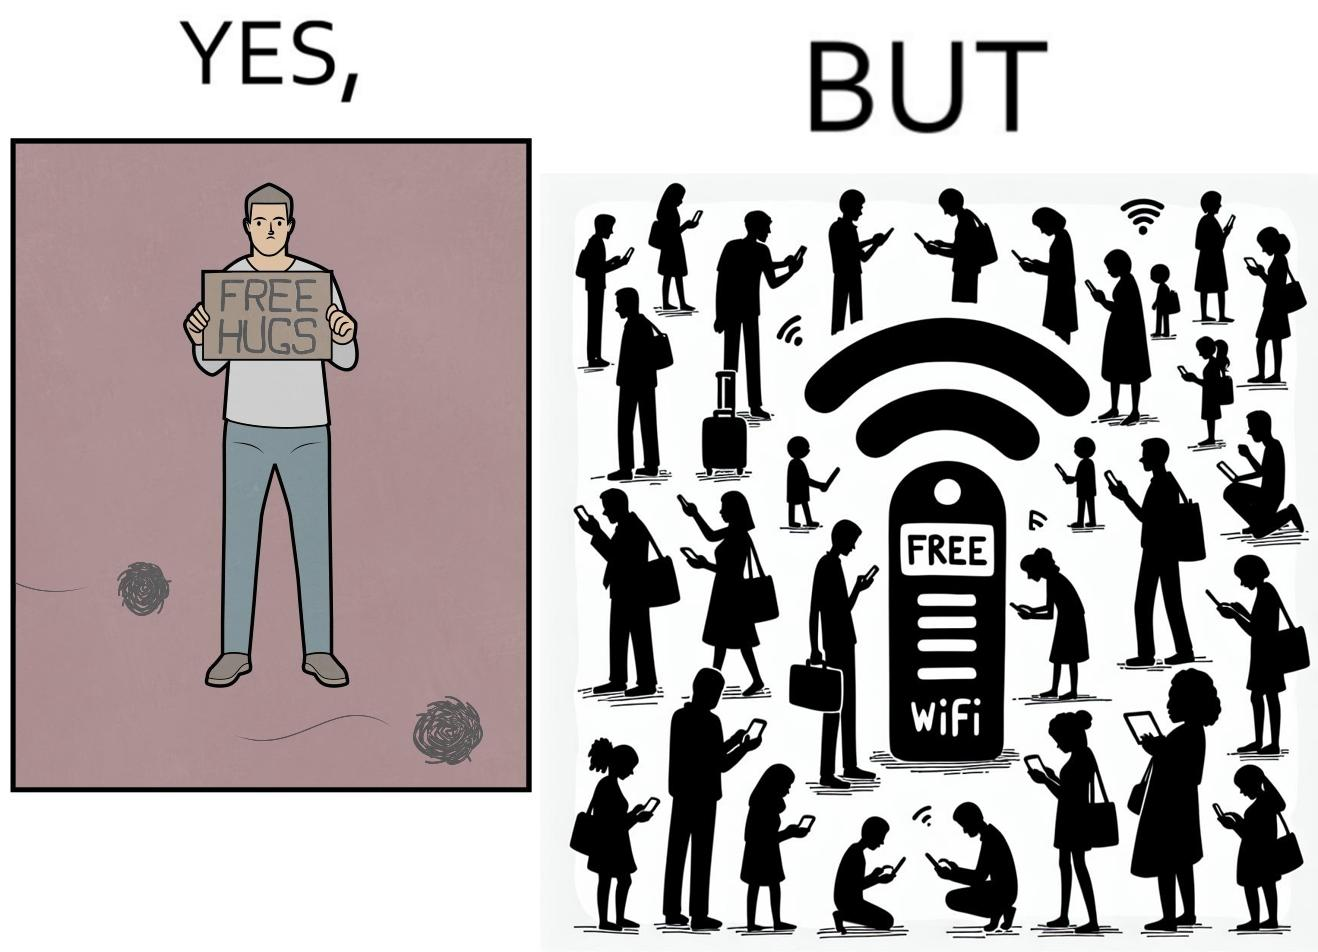Describe the satirical element in this image. This image is ironical, as a person holding up a "Free Hugs" sign is standing alone, while an inanimate Wi-fi Router giving "Free Wifi" is surrounded people trying to connect to it. This shows a growing lack of empathy in our society, while showing our increasing dependence on the digital devices in a virtual world. 